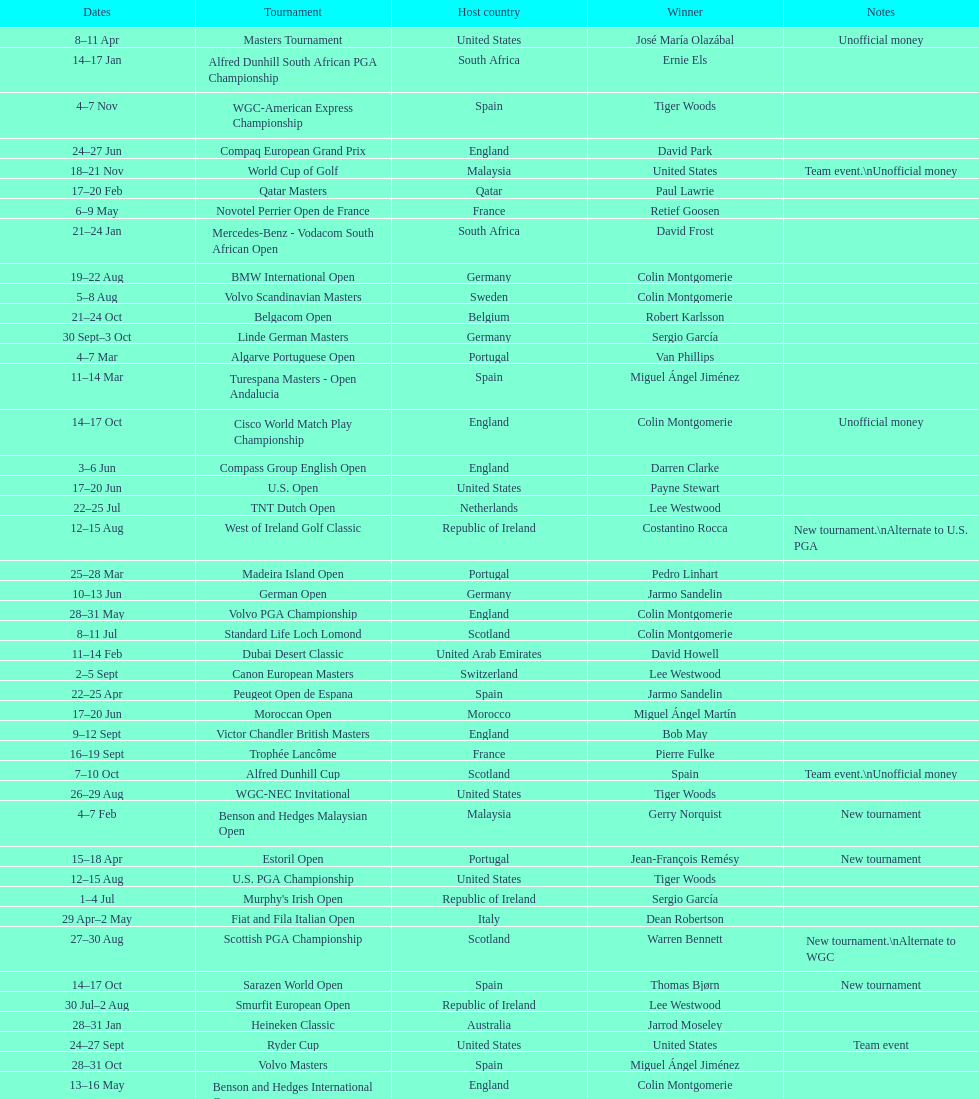Help me parse the entirety of this table. {'header': ['Dates', 'Tournament', 'Host country', 'Winner', 'Notes'], 'rows': [['8–11\xa0Apr', 'Masters Tournament', 'United States', 'José María Olazábal', 'Unofficial money'], ['14–17\xa0Jan', 'Alfred Dunhill South African PGA Championship', 'South Africa', 'Ernie Els', ''], ['4–7\xa0Nov', 'WGC-American Express Championship', 'Spain', 'Tiger Woods', ''], ['24–27\xa0Jun', 'Compaq European Grand Prix', 'England', 'David Park', ''], ['18–21\xa0Nov', 'World Cup of Golf', 'Malaysia', 'United States', 'Team event.\\nUnofficial money'], ['17–20\xa0Feb', 'Qatar Masters', 'Qatar', 'Paul Lawrie', ''], ['6–9\xa0May', 'Novotel Perrier Open de France', 'France', 'Retief Goosen', ''], ['21–24\xa0Jan', 'Mercedes-Benz - Vodacom South African Open', 'South Africa', 'David Frost', ''], ['19–22\xa0Aug', 'BMW International Open', 'Germany', 'Colin Montgomerie', ''], ['5–8\xa0Aug', 'Volvo Scandinavian Masters', 'Sweden', 'Colin Montgomerie', ''], ['21–24\xa0Oct', 'Belgacom Open', 'Belgium', 'Robert Karlsson', ''], ['30\xa0Sept–3\xa0Oct', 'Linde German Masters', 'Germany', 'Sergio García', ''], ['4–7\xa0Mar', 'Algarve Portuguese Open', 'Portugal', 'Van Phillips', ''], ['11–14\xa0Mar', 'Turespana Masters - Open Andalucia', 'Spain', 'Miguel Ángel Jiménez', ''], ['14–17\xa0Oct', 'Cisco World Match Play Championship', 'England', 'Colin Montgomerie', 'Unofficial money'], ['3–6\xa0Jun', 'Compass Group English Open', 'England', 'Darren Clarke', ''], ['17–20\xa0Jun', 'U.S. Open', 'United States', 'Payne Stewart', ''], ['22–25\xa0Jul', 'TNT Dutch Open', 'Netherlands', 'Lee Westwood', ''], ['12–15\xa0Aug', 'West of Ireland Golf Classic', 'Republic of Ireland', 'Costantino Rocca', 'New tournament.\\nAlternate to U.S. PGA'], ['25–28\xa0Mar', 'Madeira Island Open', 'Portugal', 'Pedro Linhart', ''], ['10–13\xa0Jun', 'German Open', 'Germany', 'Jarmo Sandelin', ''], ['28–31\xa0May', 'Volvo PGA Championship', 'England', 'Colin Montgomerie', ''], ['8–11\xa0Jul', 'Standard Life Loch Lomond', 'Scotland', 'Colin Montgomerie', ''], ['11–14\xa0Feb', 'Dubai Desert Classic', 'United Arab Emirates', 'David Howell', ''], ['2–5\xa0Sept', 'Canon European Masters', 'Switzerland', 'Lee Westwood', ''], ['22–25\xa0Apr', 'Peugeot Open de Espana', 'Spain', 'Jarmo Sandelin', ''], ['17–20\xa0Jun', 'Moroccan Open', 'Morocco', 'Miguel Ángel Martín', ''], ['9–12\xa0Sept', 'Victor Chandler British Masters', 'England', 'Bob May', ''], ['16–19\xa0Sept', 'Trophée Lancôme', 'France', 'Pierre Fulke', ''], ['7–10\xa0Oct', 'Alfred Dunhill Cup', 'Scotland', 'Spain', 'Team event.\\nUnofficial money'], ['26–29\xa0Aug', 'WGC-NEC Invitational', 'United States', 'Tiger Woods', ''], ['4–7\xa0Feb', 'Benson and Hedges Malaysian Open', 'Malaysia', 'Gerry Norquist', 'New tournament'], ['15–18\xa0Apr', 'Estoril Open', 'Portugal', 'Jean-François Remésy', 'New tournament'], ['12–15\xa0Aug', 'U.S. PGA Championship', 'United States', 'Tiger Woods', ''], ['1–4\xa0Jul', "Murphy's Irish Open", 'Republic of Ireland', 'Sergio García', ''], ['29\xa0Apr–2\xa0May', 'Fiat and Fila Italian Open', 'Italy', 'Dean Robertson', ''], ['27–30\xa0Aug', 'Scottish PGA Championship', 'Scotland', 'Warren Bennett', 'New tournament.\\nAlternate to WGC'], ['14–17\xa0Oct', 'Sarazen World Open', 'Spain', 'Thomas Bjørn', 'New tournament'], ['30\xa0Jul–2\xa0Aug', 'Smurfit European Open', 'Republic of Ireland', 'Lee Westwood', ''], ['28–31\xa0Jan', 'Heineken Classic', 'Australia', 'Jarrod Moseley', ''], ['24–27\xa0Sept', 'Ryder Cup', 'United States', 'United States', 'Team event'], ['28–31\xa0Oct', 'Volvo Masters', 'Spain', 'Miguel Ángel Jiménez', ''], ['13–16\xa0May', 'Benson and Hedges International Open', 'England', 'Colin Montgomerie', ''], ['24–28\xa0Feb', 'WGC-Andersen Consulting Match Play Championship', 'United States', 'Jeff Maggert', ''], ['21–24\xa0May', 'Deutsche Bank - SAP Open TPC of Europe', 'Germany', 'Tiger Woods', ''], ['15–18\xa0Jul', 'The Open Championship', 'Scotland', 'Paul Lawrie', '']]} Other than qatar masters, name a tournament that was in february. Dubai Desert Classic. 